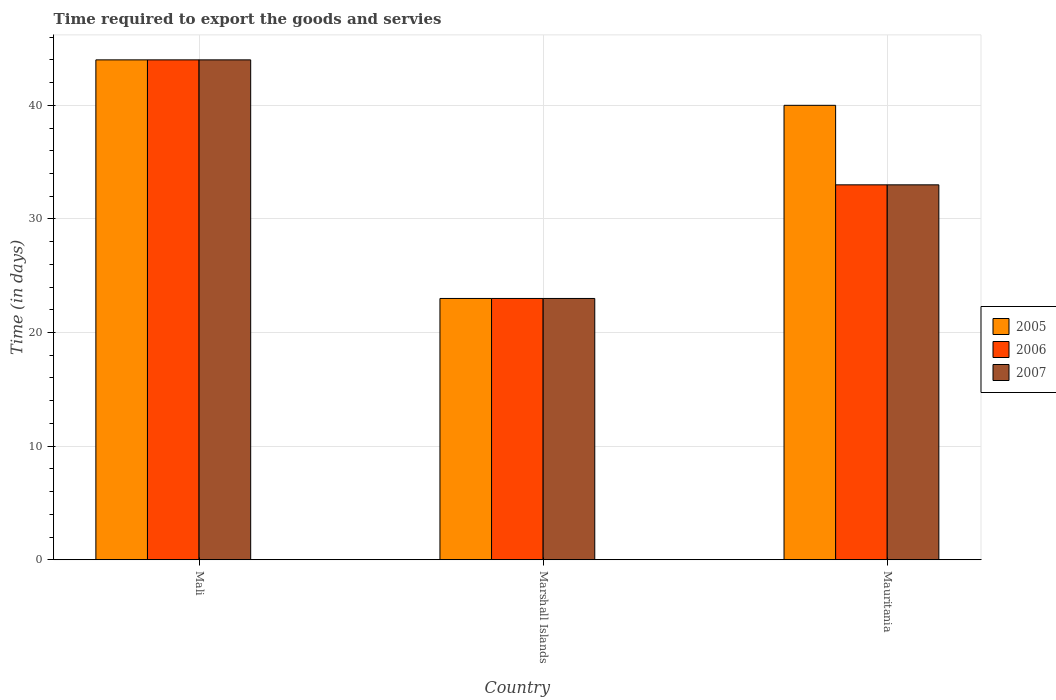How many different coloured bars are there?
Provide a succinct answer. 3. Are the number of bars per tick equal to the number of legend labels?
Provide a succinct answer. Yes. How many bars are there on the 3rd tick from the left?
Ensure brevity in your answer.  3. What is the label of the 3rd group of bars from the left?
Ensure brevity in your answer.  Mauritania. In how many cases, is the number of bars for a given country not equal to the number of legend labels?
Your answer should be compact. 0. Across all countries, what is the maximum number of days required to export the goods and services in 2007?
Your answer should be compact. 44. In which country was the number of days required to export the goods and services in 2007 maximum?
Provide a short and direct response. Mali. In which country was the number of days required to export the goods and services in 2006 minimum?
Your answer should be very brief. Marshall Islands. What is the total number of days required to export the goods and services in 2005 in the graph?
Offer a terse response. 107. What is the difference between the number of days required to export the goods and services in 2006 in Mauritania and the number of days required to export the goods and services in 2005 in Mali?
Ensure brevity in your answer.  -11. What is the average number of days required to export the goods and services in 2005 per country?
Your answer should be compact. 35.67. What is the ratio of the number of days required to export the goods and services in 2005 in Marshall Islands to that in Mauritania?
Provide a short and direct response. 0.57. Is the number of days required to export the goods and services in 2007 in Mali less than that in Marshall Islands?
Offer a terse response. No. What is the difference between the highest and the second highest number of days required to export the goods and services in 2007?
Ensure brevity in your answer.  -11. What does the 2nd bar from the left in Marshall Islands represents?
Provide a succinct answer. 2006. What does the 3rd bar from the right in Marshall Islands represents?
Ensure brevity in your answer.  2005. Is it the case that in every country, the sum of the number of days required to export the goods and services in 2006 and number of days required to export the goods and services in 2007 is greater than the number of days required to export the goods and services in 2005?
Your answer should be very brief. Yes. What is the difference between two consecutive major ticks on the Y-axis?
Your answer should be compact. 10. Are the values on the major ticks of Y-axis written in scientific E-notation?
Ensure brevity in your answer.  No. Does the graph contain any zero values?
Your answer should be compact. No. Does the graph contain grids?
Ensure brevity in your answer.  Yes. How many legend labels are there?
Offer a terse response. 3. What is the title of the graph?
Offer a terse response. Time required to export the goods and servies. Does "1984" appear as one of the legend labels in the graph?
Ensure brevity in your answer.  No. What is the label or title of the Y-axis?
Your answer should be very brief. Time (in days). What is the Time (in days) in 2005 in Mali?
Ensure brevity in your answer.  44. What is the Time (in days) in 2006 in Mali?
Your answer should be compact. 44. Across all countries, what is the maximum Time (in days) of 2007?
Make the answer very short. 44. Across all countries, what is the minimum Time (in days) of 2005?
Your answer should be very brief. 23. Across all countries, what is the minimum Time (in days) of 2006?
Offer a very short reply. 23. What is the total Time (in days) in 2005 in the graph?
Keep it short and to the point. 107. What is the total Time (in days) in 2007 in the graph?
Your answer should be very brief. 100. What is the difference between the Time (in days) of 2005 in Mali and that in Marshall Islands?
Your answer should be very brief. 21. What is the difference between the Time (in days) in 2005 in Mali and that in Mauritania?
Your answer should be very brief. 4. What is the difference between the Time (in days) in 2007 in Marshall Islands and that in Mauritania?
Your answer should be very brief. -10. What is the difference between the Time (in days) of 2005 in Mali and the Time (in days) of 2007 in Marshall Islands?
Your answer should be very brief. 21. What is the difference between the Time (in days) of 2005 in Marshall Islands and the Time (in days) of 2007 in Mauritania?
Keep it short and to the point. -10. What is the difference between the Time (in days) in 2006 in Marshall Islands and the Time (in days) in 2007 in Mauritania?
Ensure brevity in your answer.  -10. What is the average Time (in days) in 2005 per country?
Your answer should be compact. 35.67. What is the average Time (in days) of 2006 per country?
Provide a succinct answer. 33.33. What is the average Time (in days) in 2007 per country?
Give a very brief answer. 33.33. What is the difference between the Time (in days) in 2005 and Time (in days) in 2006 in Mali?
Offer a terse response. 0. What is the difference between the Time (in days) of 2005 and Time (in days) of 2006 in Marshall Islands?
Offer a terse response. 0. What is the difference between the Time (in days) in 2005 and Time (in days) in 2007 in Marshall Islands?
Provide a short and direct response. 0. What is the difference between the Time (in days) of 2005 and Time (in days) of 2006 in Mauritania?
Make the answer very short. 7. What is the difference between the Time (in days) in 2005 and Time (in days) in 2007 in Mauritania?
Give a very brief answer. 7. What is the ratio of the Time (in days) in 2005 in Mali to that in Marshall Islands?
Provide a short and direct response. 1.91. What is the ratio of the Time (in days) in 2006 in Mali to that in Marshall Islands?
Your answer should be very brief. 1.91. What is the ratio of the Time (in days) in 2007 in Mali to that in Marshall Islands?
Provide a short and direct response. 1.91. What is the ratio of the Time (in days) in 2006 in Mali to that in Mauritania?
Offer a terse response. 1.33. What is the ratio of the Time (in days) in 2007 in Mali to that in Mauritania?
Provide a short and direct response. 1.33. What is the ratio of the Time (in days) of 2005 in Marshall Islands to that in Mauritania?
Provide a short and direct response. 0.57. What is the ratio of the Time (in days) of 2006 in Marshall Islands to that in Mauritania?
Your response must be concise. 0.7. What is the ratio of the Time (in days) in 2007 in Marshall Islands to that in Mauritania?
Provide a short and direct response. 0.7. What is the difference between the highest and the second highest Time (in days) in 2007?
Offer a terse response. 11. What is the difference between the highest and the lowest Time (in days) in 2006?
Make the answer very short. 21. 